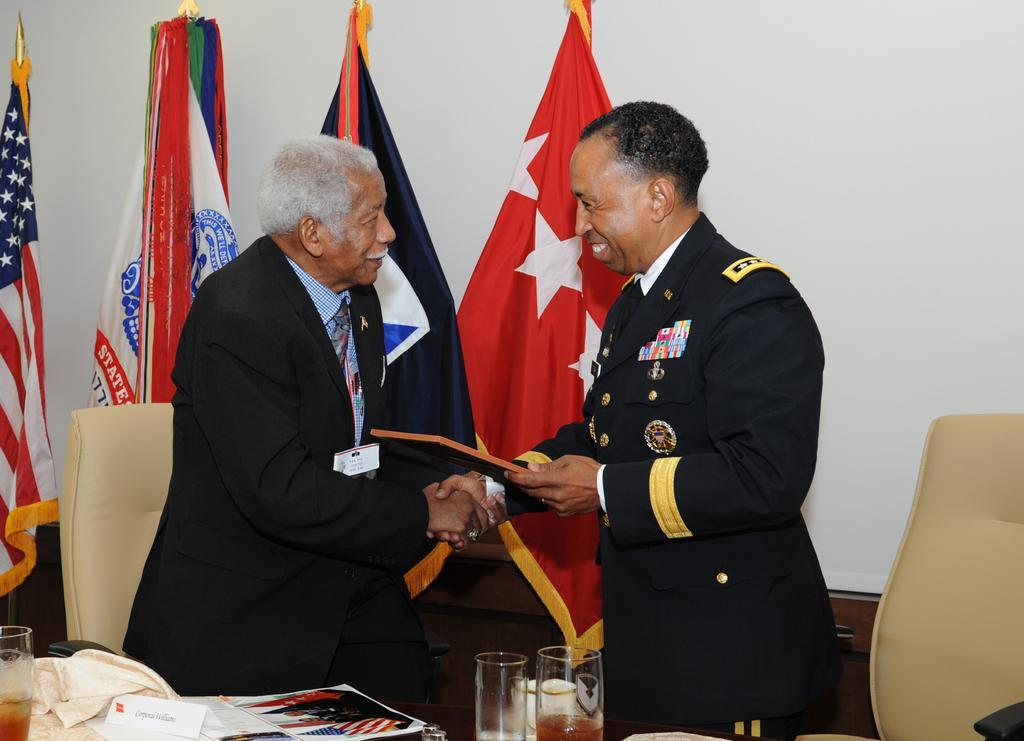How would you summarize this image in a sentence or two? The two persons are standing. They are smiling. They are wearing a id card. On the right side of the person is holding a book. There is a table. There is a glass,paper,cloth on a table. We can see in the background flags and wall. 